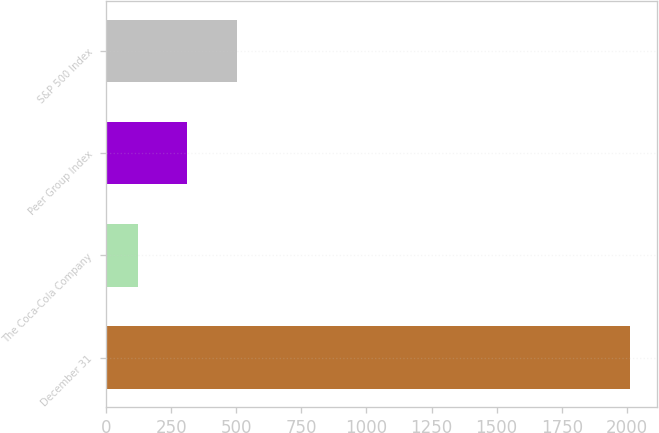Convert chart to OTSL. <chart><loc_0><loc_0><loc_500><loc_500><bar_chart><fcel>December 31<fcel>The Coca-Cola Company<fcel>Peer Group Index<fcel>S&P 500 Index<nl><fcel>2014<fcel>123<fcel>312.1<fcel>501.2<nl></chart> 